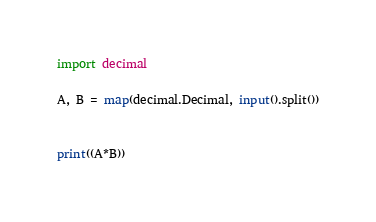<code> <loc_0><loc_0><loc_500><loc_500><_Python_>import decimal

A, B = map(decimal.Decimal, input().split())


print((A*B))
</code> 